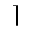<formula> <loc_0><loc_0><loc_500><loc_500>\rceil</formula> 